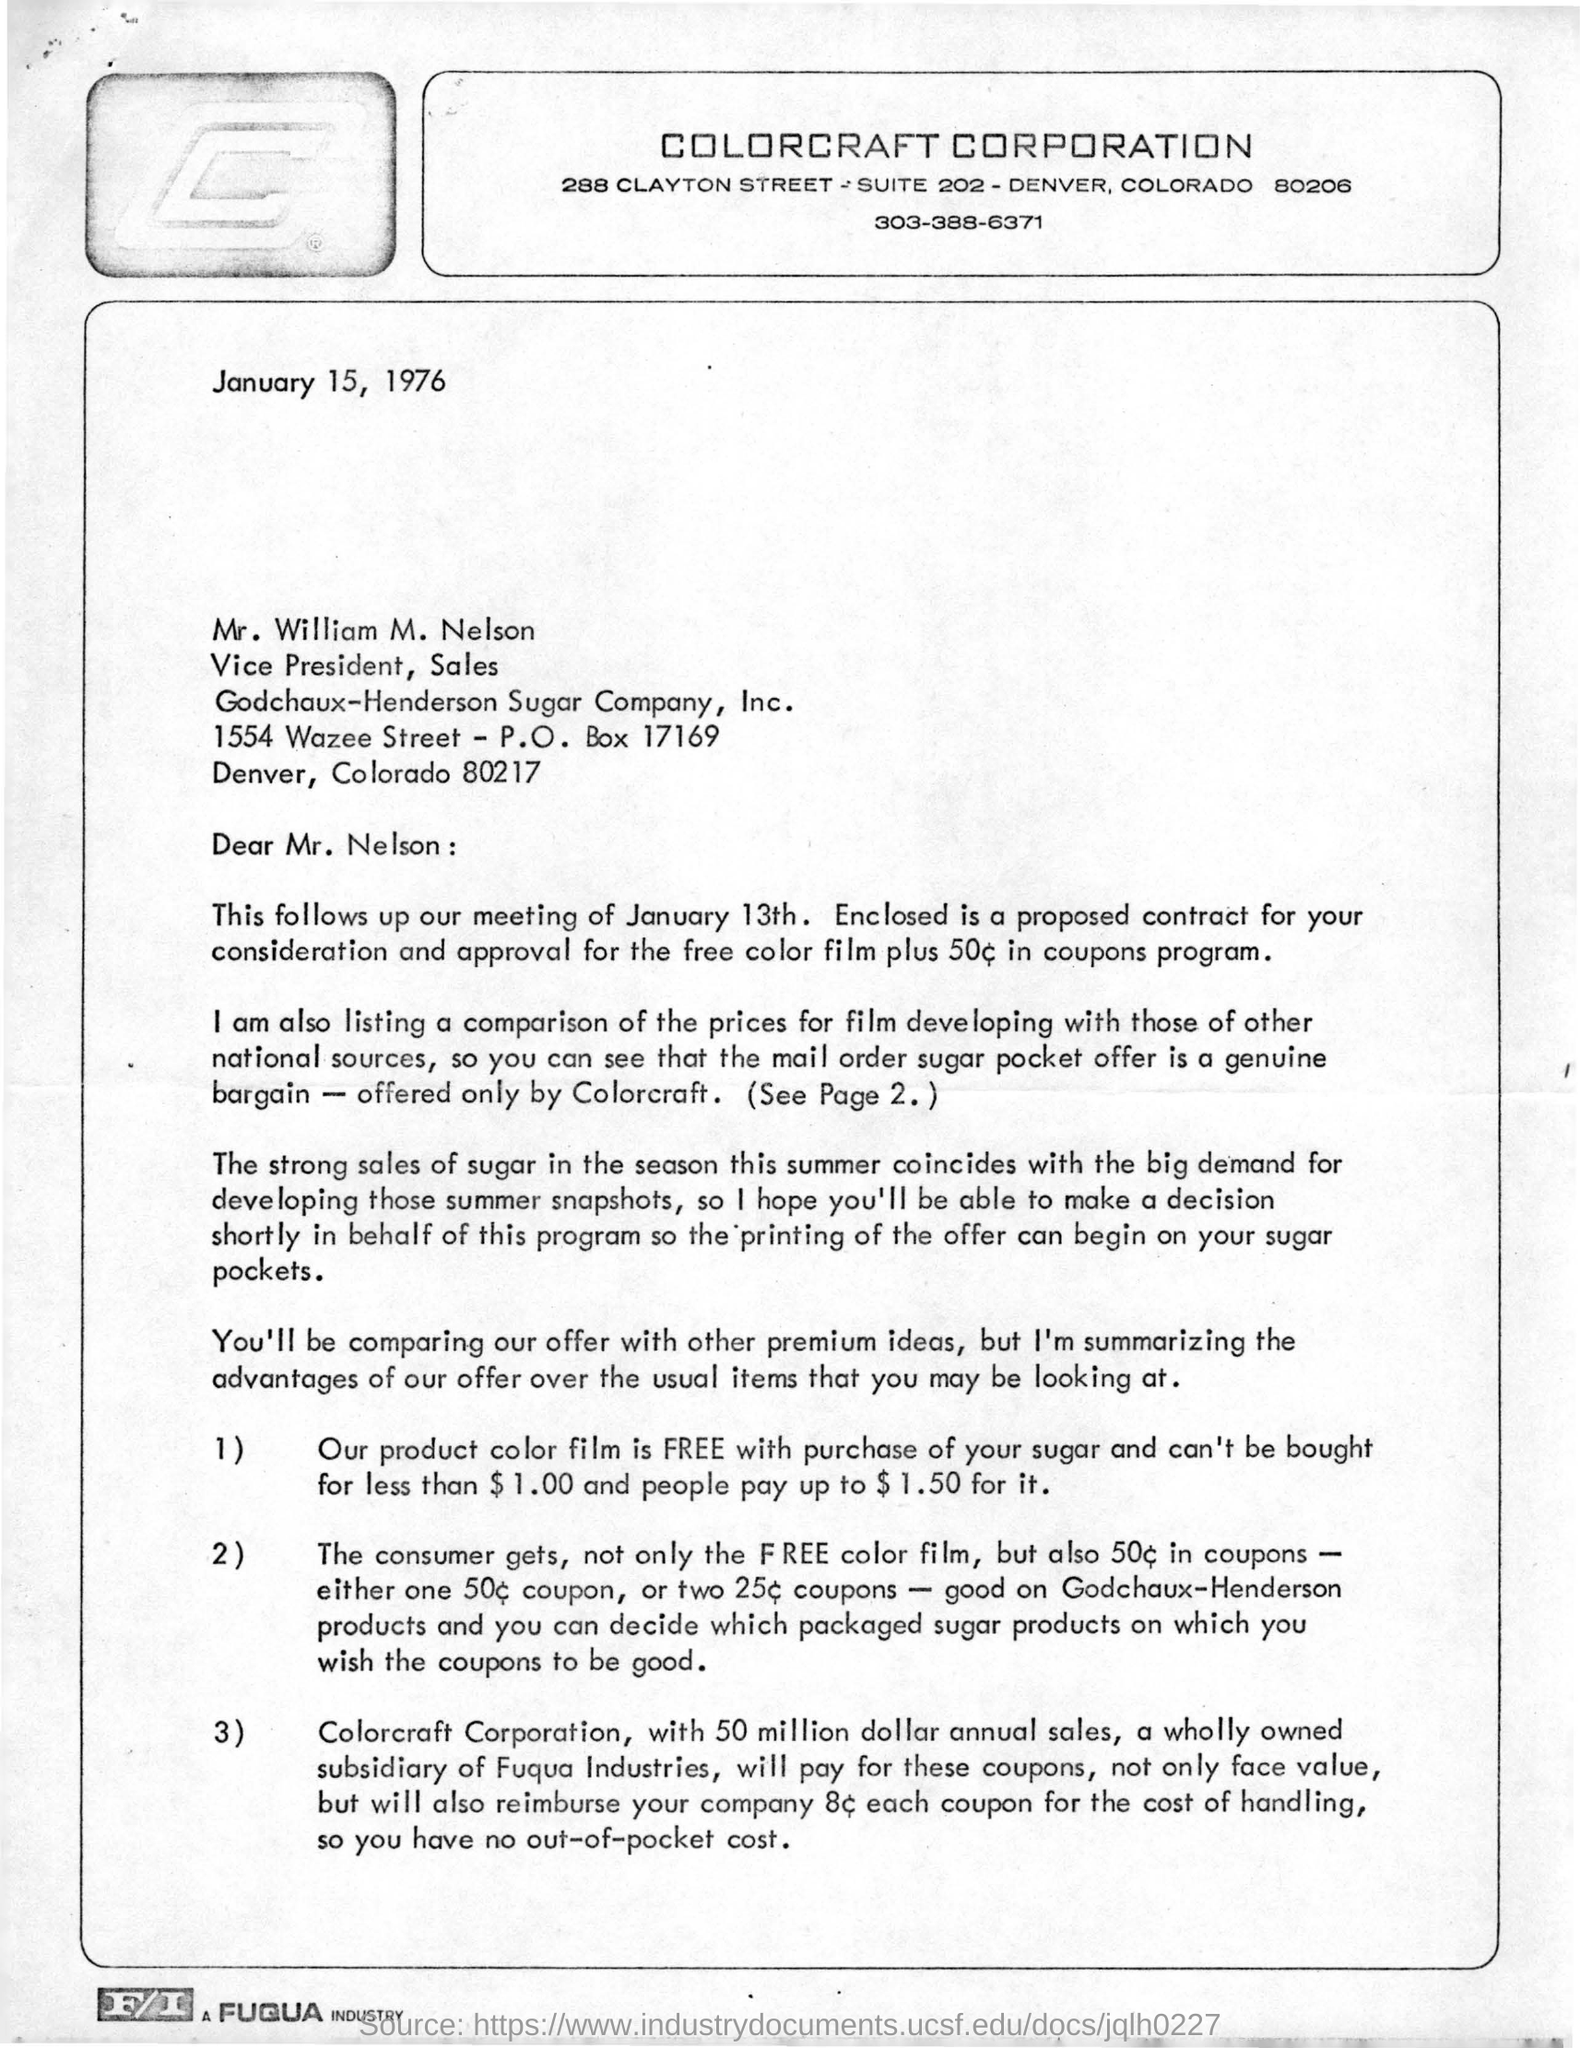Which company's letter head is this?
Make the answer very short. Colorcraft Corporation. What is date of this letter?
Provide a short and direct response. January 15, 1976. To whom this letter addressed?
Give a very brief answer. William M. Nelson. What is receiver's post box number?
Your response must be concise. 17169. When the meeting held?
Give a very brief answer. January 13th. What's the annual sales of Colorcraft Corporation?
Your response must be concise. 50 million dollar. 